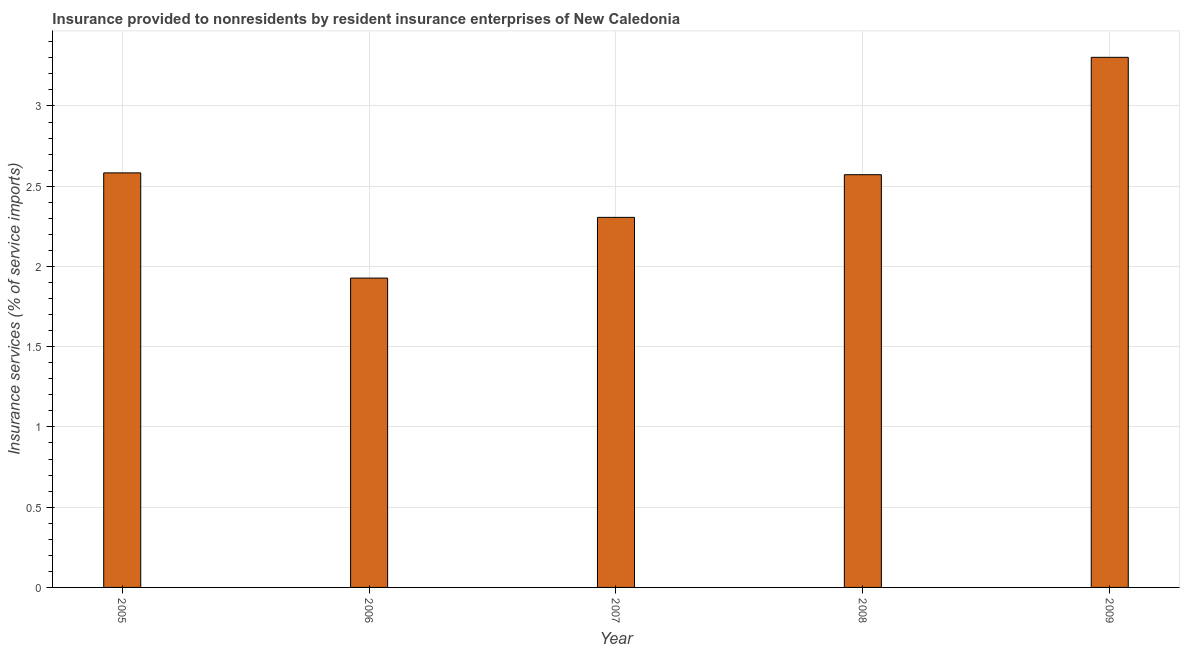Does the graph contain grids?
Give a very brief answer. Yes. What is the title of the graph?
Offer a very short reply. Insurance provided to nonresidents by resident insurance enterprises of New Caledonia. What is the label or title of the Y-axis?
Offer a terse response. Insurance services (% of service imports). What is the insurance and financial services in 2005?
Your answer should be very brief. 2.58. Across all years, what is the maximum insurance and financial services?
Your response must be concise. 3.3. Across all years, what is the minimum insurance and financial services?
Keep it short and to the point. 1.93. In which year was the insurance and financial services minimum?
Ensure brevity in your answer.  2006. What is the sum of the insurance and financial services?
Keep it short and to the point. 12.69. What is the difference between the insurance and financial services in 2008 and 2009?
Your response must be concise. -0.73. What is the average insurance and financial services per year?
Give a very brief answer. 2.54. What is the median insurance and financial services?
Provide a succinct answer. 2.57. What is the ratio of the insurance and financial services in 2007 to that in 2008?
Ensure brevity in your answer.  0.9. Is the insurance and financial services in 2005 less than that in 2006?
Offer a terse response. No. What is the difference between the highest and the second highest insurance and financial services?
Keep it short and to the point. 0.72. Is the sum of the insurance and financial services in 2006 and 2007 greater than the maximum insurance and financial services across all years?
Offer a very short reply. Yes. What is the difference between the highest and the lowest insurance and financial services?
Keep it short and to the point. 1.38. In how many years, is the insurance and financial services greater than the average insurance and financial services taken over all years?
Give a very brief answer. 3. How many bars are there?
Provide a succinct answer. 5. How many years are there in the graph?
Provide a short and direct response. 5. Are the values on the major ticks of Y-axis written in scientific E-notation?
Offer a terse response. No. What is the Insurance services (% of service imports) in 2005?
Ensure brevity in your answer.  2.58. What is the Insurance services (% of service imports) in 2006?
Give a very brief answer. 1.93. What is the Insurance services (% of service imports) in 2007?
Give a very brief answer. 2.31. What is the Insurance services (% of service imports) in 2008?
Your answer should be compact. 2.57. What is the Insurance services (% of service imports) in 2009?
Make the answer very short. 3.3. What is the difference between the Insurance services (% of service imports) in 2005 and 2006?
Provide a short and direct response. 0.66. What is the difference between the Insurance services (% of service imports) in 2005 and 2007?
Offer a very short reply. 0.28. What is the difference between the Insurance services (% of service imports) in 2005 and 2008?
Offer a terse response. 0.01. What is the difference between the Insurance services (% of service imports) in 2005 and 2009?
Your answer should be very brief. -0.72. What is the difference between the Insurance services (% of service imports) in 2006 and 2007?
Make the answer very short. -0.38. What is the difference between the Insurance services (% of service imports) in 2006 and 2008?
Provide a succinct answer. -0.64. What is the difference between the Insurance services (% of service imports) in 2006 and 2009?
Your answer should be very brief. -1.38. What is the difference between the Insurance services (% of service imports) in 2007 and 2008?
Offer a very short reply. -0.27. What is the difference between the Insurance services (% of service imports) in 2007 and 2009?
Your response must be concise. -1. What is the difference between the Insurance services (% of service imports) in 2008 and 2009?
Make the answer very short. -0.73. What is the ratio of the Insurance services (% of service imports) in 2005 to that in 2006?
Your answer should be very brief. 1.34. What is the ratio of the Insurance services (% of service imports) in 2005 to that in 2007?
Provide a short and direct response. 1.12. What is the ratio of the Insurance services (% of service imports) in 2005 to that in 2008?
Your response must be concise. 1. What is the ratio of the Insurance services (% of service imports) in 2005 to that in 2009?
Your answer should be compact. 0.78. What is the ratio of the Insurance services (% of service imports) in 2006 to that in 2007?
Your answer should be compact. 0.84. What is the ratio of the Insurance services (% of service imports) in 2006 to that in 2008?
Make the answer very short. 0.75. What is the ratio of the Insurance services (% of service imports) in 2006 to that in 2009?
Your answer should be compact. 0.58. What is the ratio of the Insurance services (% of service imports) in 2007 to that in 2008?
Offer a terse response. 0.9. What is the ratio of the Insurance services (% of service imports) in 2007 to that in 2009?
Your answer should be very brief. 0.7. What is the ratio of the Insurance services (% of service imports) in 2008 to that in 2009?
Your answer should be very brief. 0.78. 